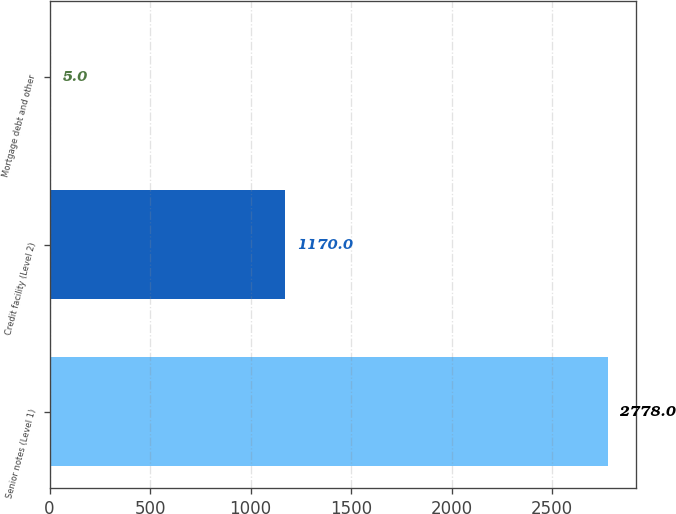Convert chart to OTSL. <chart><loc_0><loc_0><loc_500><loc_500><bar_chart><fcel>Senior notes (Level 1)<fcel>Credit facility (Level 2)<fcel>Mortgage debt and other<nl><fcel>2778<fcel>1170<fcel>5<nl></chart> 